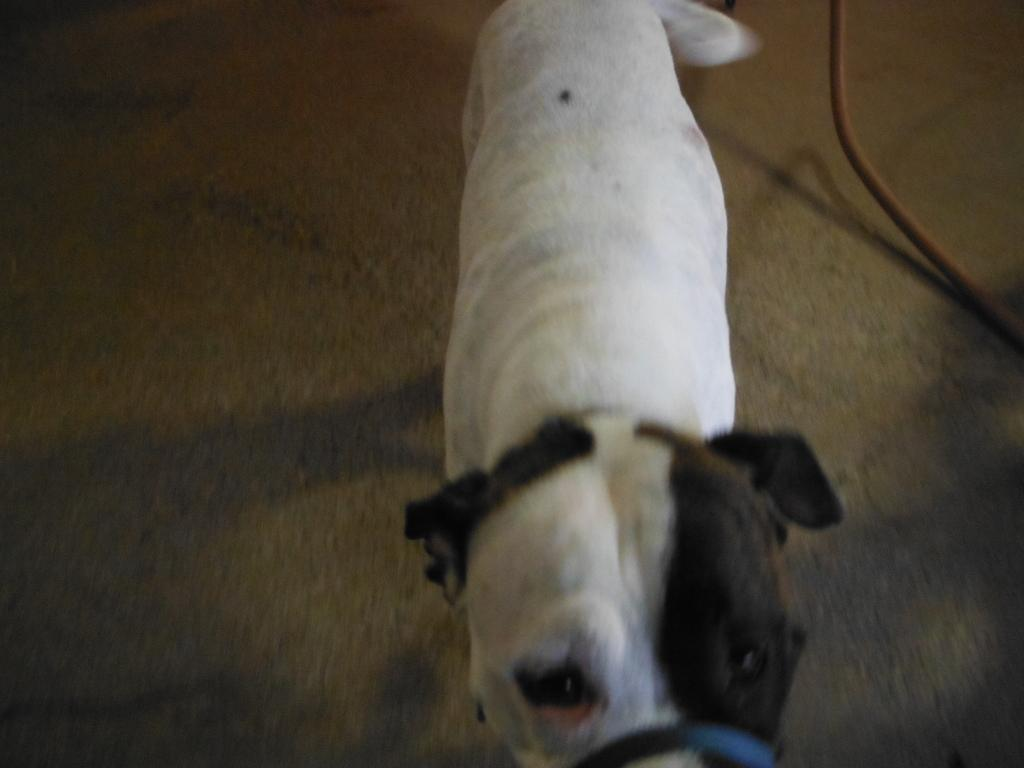What type of animal is in the picture? There is a dog in the picture. Can you describe the color of the dog? The dog is white and brown in color. What can be seen in the right corner of the image? There is a pipe in the right corner of the image. How many eyes does the face on the seat have in the image? There is no face or seat present in the image; it features a dog and a pipe. 